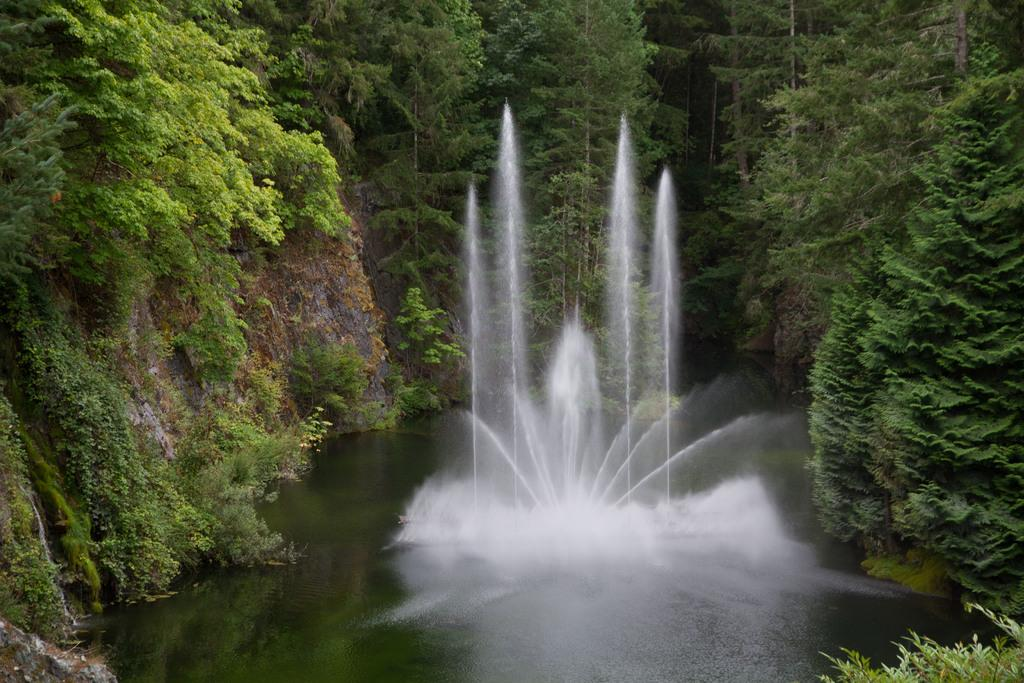What is the main feature in the image? There is a fountain in the image. What can be seen in the background of the image? There are trees in the background of the image. What is the color of the trees in the image? The trees are green in color. What verse is being recited by the friends near the fountain in the image? There are no friends or any recitation of verses present in the image; it only features a fountain and trees. 